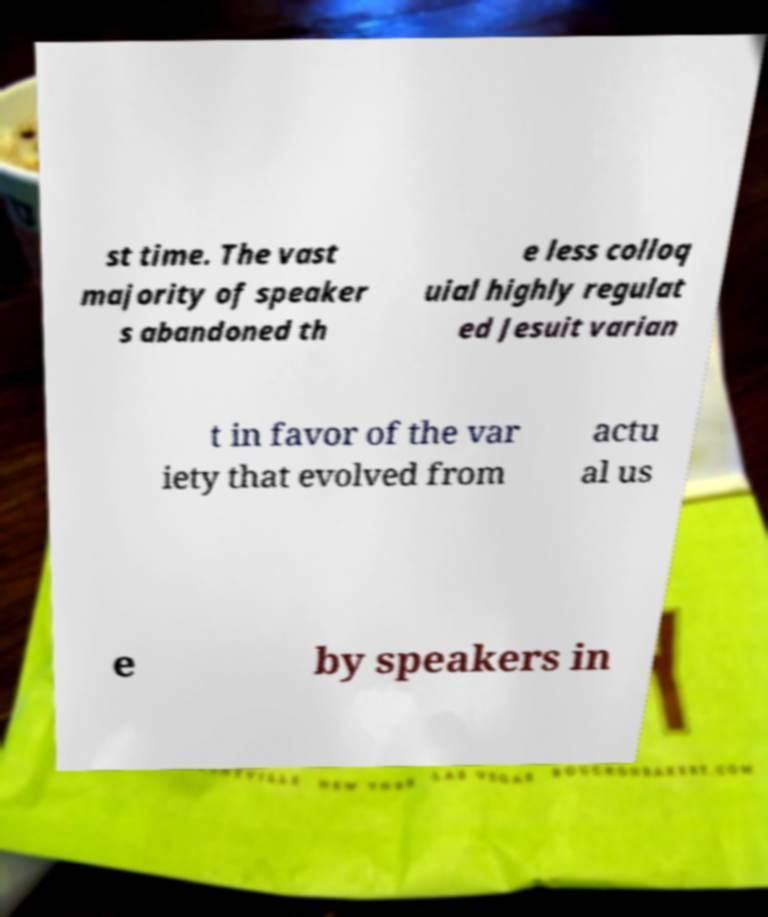Could you assist in decoding the text presented in this image and type it out clearly? st time. The vast majority of speaker s abandoned th e less colloq uial highly regulat ed Jesuit varian t in favor of the var iety that evolved from actu al us e by speakers in 